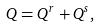Convert formula to latex. <formula><loc_0><loc_0><loc_500><loc_500>Q = Q ^ { r } + Q ^ { s } ,</formula> 